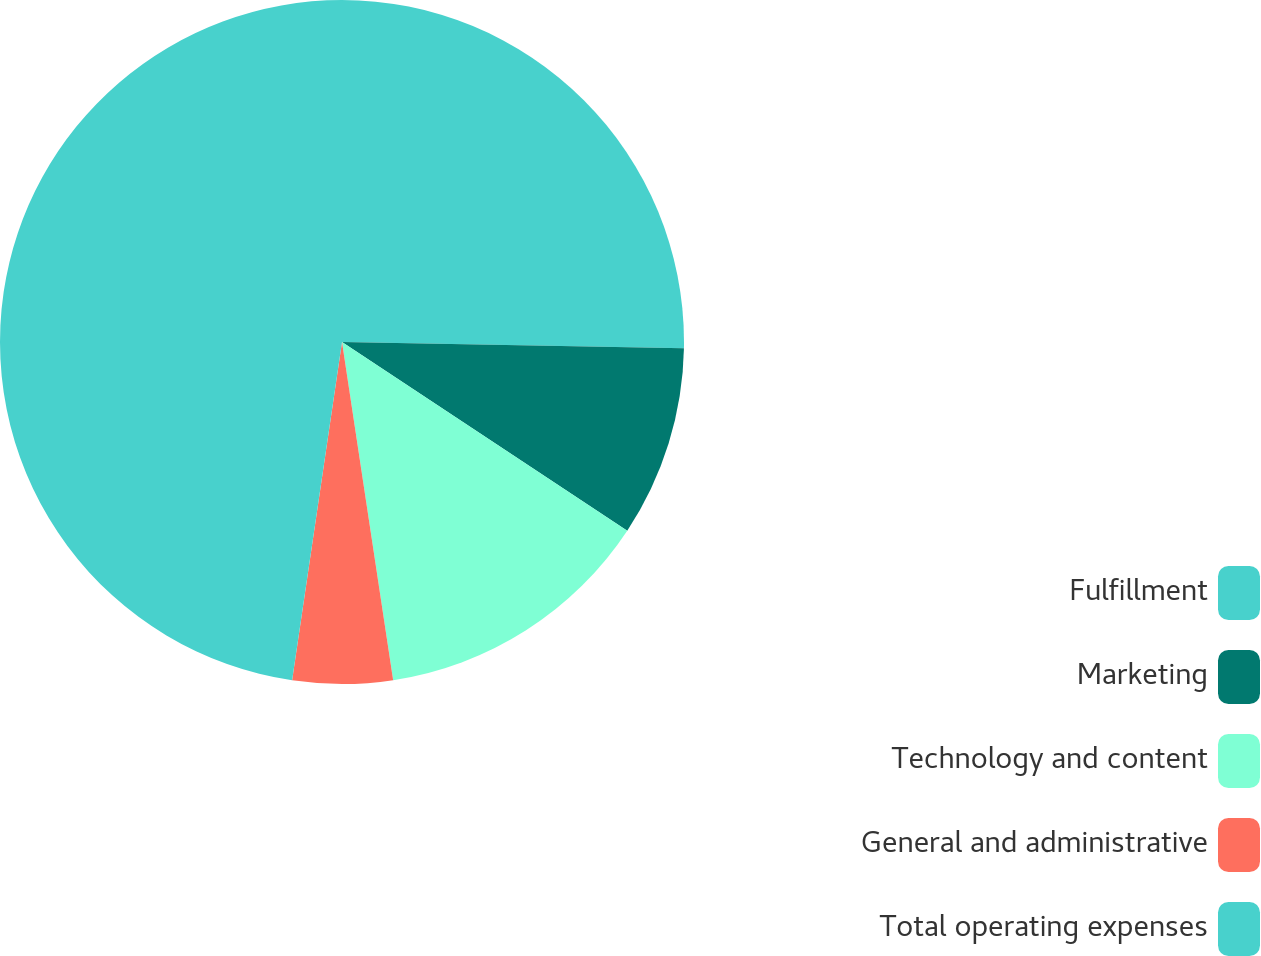<chart> <loc_0><loc_0><loc_500><loc_500><pie_chart><fcel>Fulfillment<fcel>Marketing<fcel>Technology and content<fcel>General and administrative<fcel>Total operating expenses<nl><fcel>25.29%<fcel>9.01%<fcel>13.31%<fcel>4.72%<fcel>47.67%<nl></chart> 